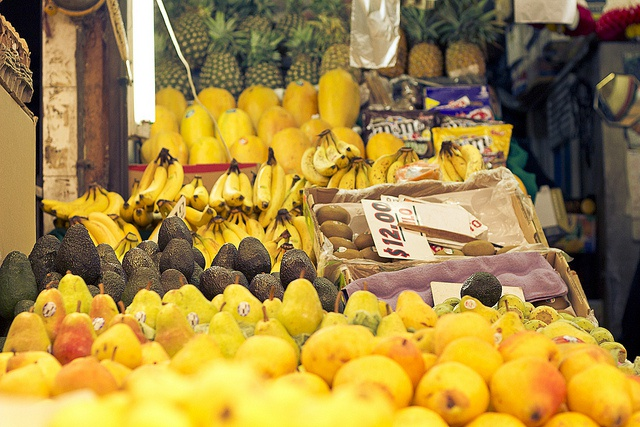Describe the objects in this image and their specific colors. I can see banana in red, orange, gold, and olive tones, banana in red, orange, gold, and olive tones, banana in red, gold, orange, and olive tones, banana in red, gold, orange, olive, and maroon tones, and banana in red, orange, khaki, olive, and tan tones in this image. 